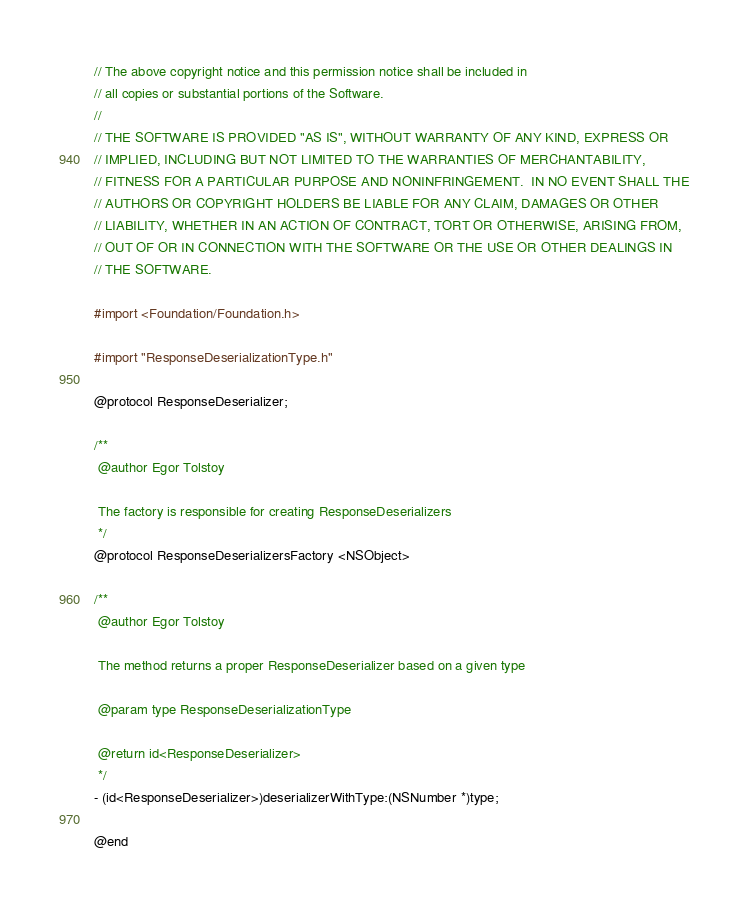<code> <loc_0><loc_0><loc_500><loc_500><_C_>// The above copyright notice and this permission notice shall be included in
// all copies or substantial portions of the Software.
//
// THE SOFTWARE IS PROVIDED "AS IS", WITHOUT WARRANTY OF ANY KIND, EXPRESS OR
// IMPLIED, INCLUDING BUT NOT LIMITED TO THE WARRANTIES OF MERCHANTABILITY,
// FITNESS FOR A PARTICULAR PURPOSE AND NONINFRINGEMENT.  IN NO EVENT SHALL THE
// AUTHORS OR COPYRIGHT HOLDERS BE LIABLE FOR ANY CLAIM, DAMAGES OR OTHER
// LIABILITY, WHETHER IN AN ACTION OF CONTRACT, TORT OR OTHERWISE, ARISING FROM,
// OUT OF OR IN CONNECTION WITH THE SOFTWARE OR THE USE OR OTHER DEALINGS IN
// THE SOFTWARE.

#import <Foundation/Foundation.h>

#import "ResponseDeserializationType.h"

@protocol ResponseDeserializer;

/**
 @author Egor Tolstoy
 
 The factory is responsible for creating ResponseDeserializers
 */
@protocol ResponseDeserializersFactory <NSObject>

/**
 @author Egor Tolstoy
 
 The method returns a proper ResponseDeserializer based on a given type
 
 @param type ResponseDeserializationType
 
 @return id<ResponseDeserializer>
 */
- (id<ResponseDeserializer>)deserializerWithType:(NSNumber *)type;

@end
</code> 